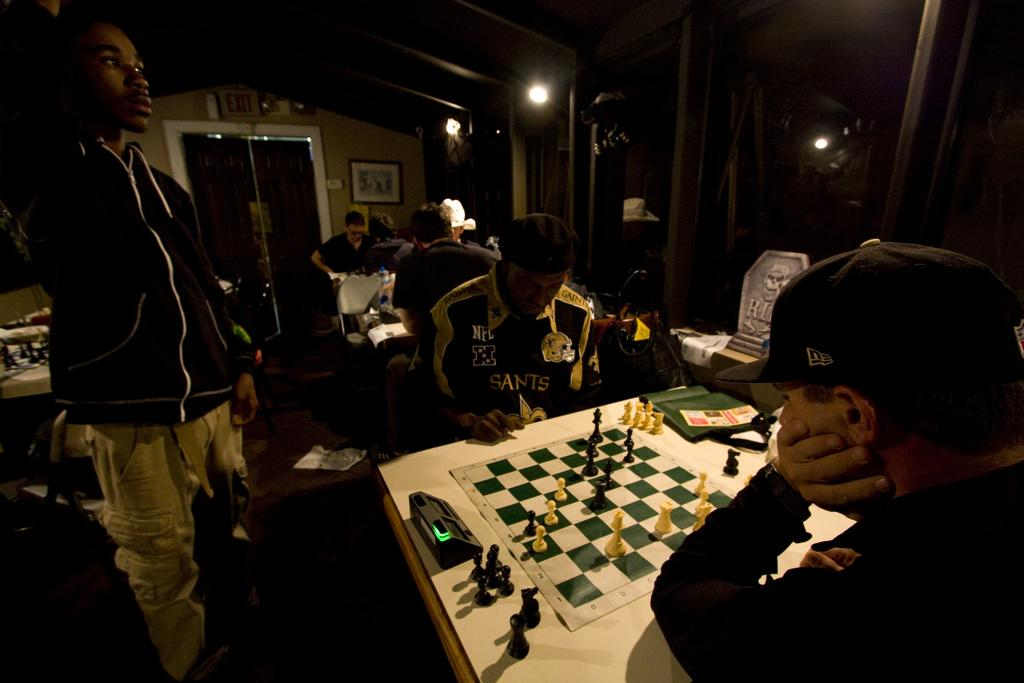What are the people in the image doing? The people in the image are playing a chess game. How are the people positioned while playing the game? The people are sitting on chairs. Is there anyone else in the image besides the people playing the game? Yes, there is a person standing on the left side of the image. What type of shoes is the actor wearing in the image? There is no actor or shoes mentioned in the image; it features a group of people playing chess and a person standing nearby. 